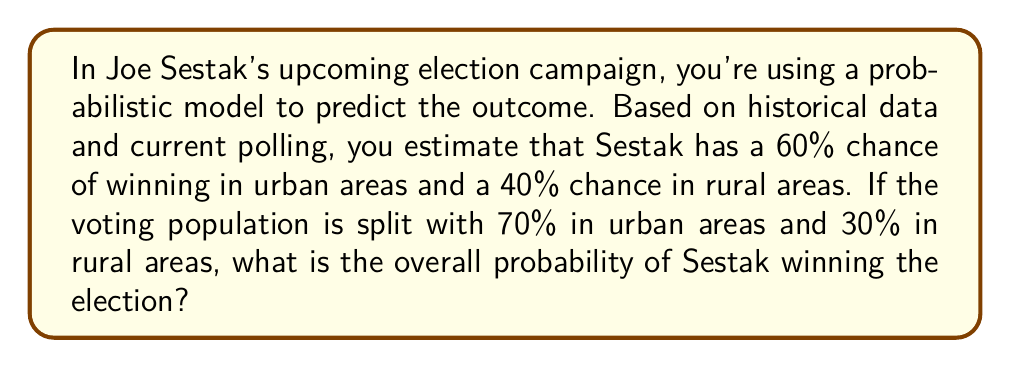Give your solution to this math problem. To solve this problem, we need to use the law of total probability. Let's break it down step-by-step:

1) Let's define our events:
   A: Sestak wins the election
   U: Urban area
   R: Rural area

2) We're given the following probabilities:
   $P(A|U) = 0.60$ (probability of winning in urban areas)
   $P(A|R) = 0.40$ (probability of winning in rural areas)
   $P(U) = 0.70$ (proportion of urban voters)
   $P(R) = 0.30$ (proportion of rural voters)

3) The law of total probability states:
   $P(A) = P(A|U) \cdot P(U) + P(A|R) \cdot P(R)$

4) Let's substitute our values:
   $P(A) = 0.60 \cdot 0.70 + 0.40 \cdot 0.30$

5) Now we can calculate:
   $P(A) = 0.42 + 0.12$
   $P(A) = 0.54$

6) Convert to a percentage:
   $0.54 \cdot 100\% = 54\%$

Therefore, based on this probabilistic model, Sestak has a 54% chance of winning the election overall.
Answer: 54% 